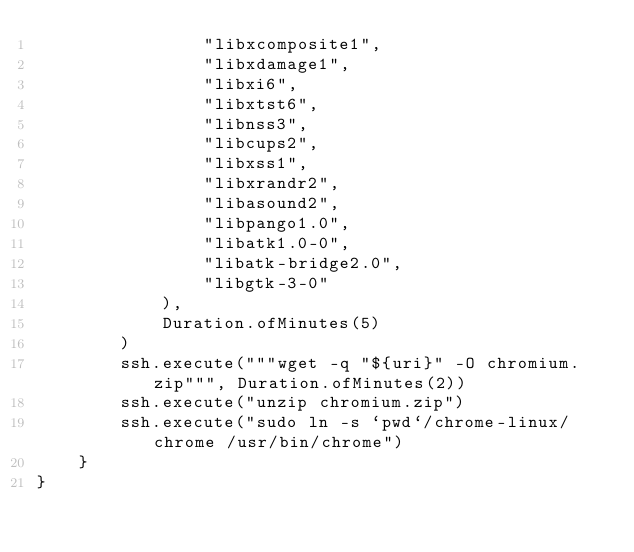Convert code to text. <code><loc_0><loc_0><loc_500><loc_500><_Kotlin_>                "libxcomposite1",
                "libxdamage1",
                "libxi6",
                "libxtst6",
                "libnss3",
                "libcups2",
                "libxss1",
                "libxrandr2",
                "libasound2",
                "libpango1.0",
                "libatk1.0-0",
                "libatk-bridge2.0",
                "libgtk-3-0"
            ),
            Duration.ofMinutes(5)
        )
        ssh.execute("""wget -q "${uri}" -O chromium.zip""", Duration.ofMinutes(2))
        ssh.execute("unzip chromium.zip")
        ssh.execute("sudo ln -s `pwd`/chrome-linux/chrome /usr/bin/chrome")
    }
}</code> 